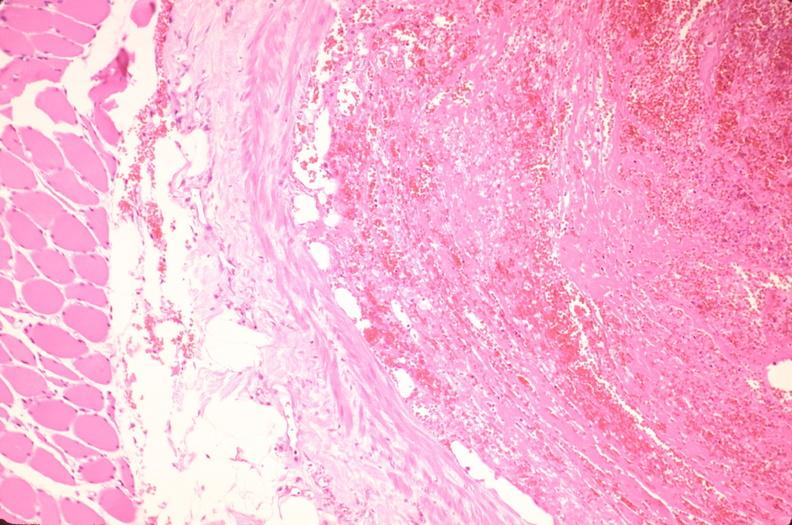does mesothelioma show thrombus in leg vein with early organization?
Answer the question using a single word or phrase. No 